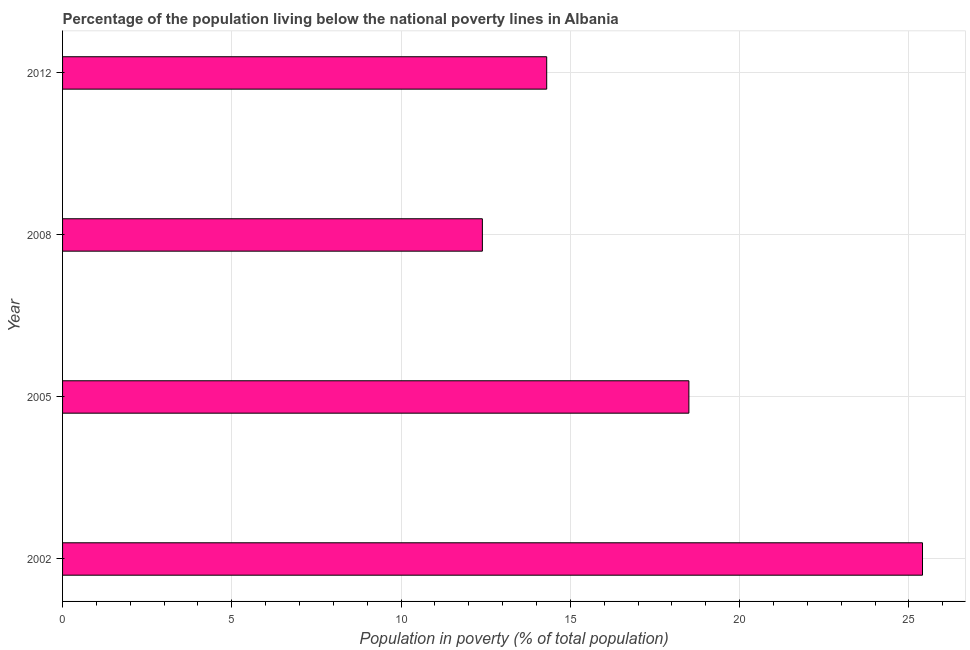Does the graph contain any zero values?
Your answer should be compact. No. What is the title of the graph?
Give a very brief answer. Percentage of the population living below the national poverty lines in Albania. What is the label or title of the X-axis?
Keep it short and to the point. Population in poverty (% of total population). What is the percentage of population living below poverty line in 2008?
Your response must be concise. 12.4. Across all years, what is the maximum percentage of population living below poverty line?
Provide a succinct answer. 25.4. Across all years, what is the minimum percentage of population living below poverty line?
Your answer should be compact. 12.4. What is the sum of the percentage of population living below poverty line?
Offer a very short reply. 70.6. What is the difference between the percentage of population living below poverty line in 2002 and 2005?
Your answer should be compact. 6.9. What is the average percentage of population living below poverty line per year?
Ensure brevity in your answer.  17.65. What is the median percentage of population living below poverty line?
Make the answer very short. 16.4. Do a majority of the years between 2008 and 2005 (inclusive) have percentage of population living below poverty line greater than 1 %?
Offer a terse response. No. What is the ratio of the percentage of population living below poverty line in 2002 to that in 2008?
Offer a very short reply. 2.05. Is the difference between the percentage of population living below poverty line in 2005 and 2012 greater than the difference between any two years?
Your answer should be compact. No. What is the difference between the highest and the lowest percentage of population living below poverty line?
Your answer should be compact. 13. How many bars are there?
Ensure brevity in your answer.  4. Are the values on the major ticks of X-axis written in scientific E-notation?
Your response must be concise. No. What is the Population in poverty (% of total population) of 2002?
Ensure brevity in your answer.  25.4. What is the Population in poverty (% of total population) of 2005?
Provide a succinct answer. 18.5. What is the Population in poverty (% of total population) of 2008?
Ensure brevity in your answer.  12.4. What is the Population in poverty (% of total population) of 2012?
Ensure brevity in your answer.  14.3. What is the difference between the Population in poverty (% of total population) in 2002 and 2005?
Offer a very short reply. 6.9. What is the difference between the Population in poverty (% of total population) in 2002 and 2008?
Provide a succinct answer. 13. What is the difference between the Population in poverty (% of total population) in 2002 and 2012?
Your answer should be compact. 11.1. What is the ratio of the Population in poverty (% of total population) in 2002 to that in 2005?
Your answer should be very brief. 1.37. What is the ratio of the Population in poverty (% of total population) in 2002 to that in 2008?
Offer a very short reply. 2.05. What is the ratio of the Population in poverty (% of total population) in 2002 to that in 2012?
Make the answer very short. 1.78. What is the ratio of the Population in poverty (% of total population) in 2005 to that in 2008?
Your response must be concise. 1.49. What is the ratio of the Population in poverty (% of total population) in 2005 to that in 2012?
Make the answer very short. 1.29. What is the ratio of the Population in poverty (% of total population) in 2008 to that in 2012?
Make the answer very short. 0.87. 